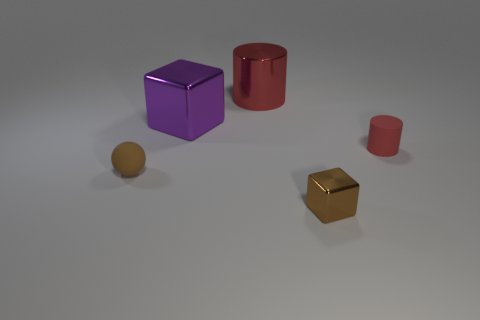Does the ball have the same material as the big thing left of the red shiny thing?
Provide a short and direct response. No. Does the matte thing to the right of the purple metal cube have the same color as the large metallic cylinder?
Offer a very short reply. Yes. What number of other things are there of the same color as the small matte cylinder?
Keep it short and to the point. 1. What size is the cube behind the tiny brown block?
Your response must be concise. Large. The red cylinder that is left of the brown object that is on the right side of the metal cube to the left of the brown shiny block is made of what material?
Offer a terse response. Metal. Is there a brown metallic block of the same size as the matte cylinder?
Your answer should be compact. Yes. There is a cylinder that is the same size as the rubber ball; what is its material?
Your answer should be compact. Rubber. There is a brown matte object that is in front of the big metallic block; what is its shape?
Offer a very short reply. Sphere. Is the small object behind the small brown rubber object made of the same material as the tiny thing that is left of the tiny metal object?
Give a very brief answer. Yes. How many other large metallic objects are the same shape as the brown metal object?
Provide a short and direct response. 1. 